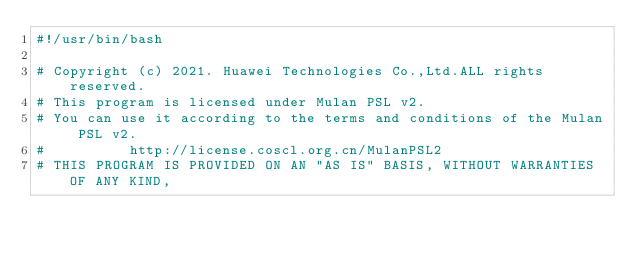Convert code to text. <code><loc_0><loc_0><loc_500><loc_500><_Bash_>#!/usr/bin/bash

# Copyright (c) 2021. Huawei Technologies Co.,Ltd.ALL rights reserved.
# This program is licensed under Mulan PSL v2.
# You can use it according to the terms and conditions of the Mulan PSL v2.
#          http://license.coscl.org.cn/MulanPSL2
# THIS PROGRAM IS PROVIDED ON AN "AS IS" BASIS, WITHOUT WARRANTIES OF ANY KIND,</code> 